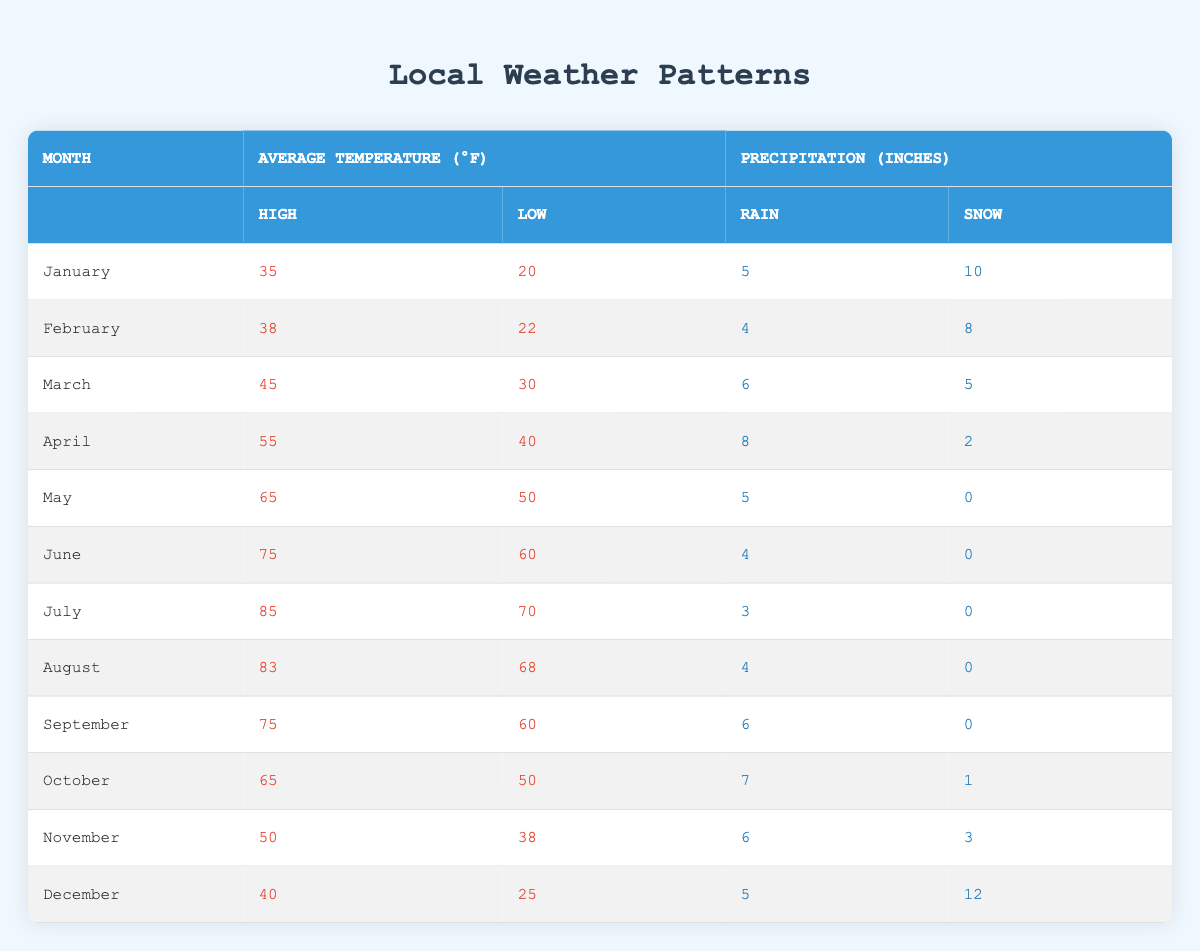What is the average high temperature in June? The high temperature for June is listed as 75°F in the table. Since we are looking for the average and there is only one value for June, the average high temperature equals the high for that month.
Answer: 75°F In which month do we see the highest low temperature? By inspecting the table, the highest low temperature is found in July, which is 70°F. This is the highest value of the low temperatures provided for all months.
Answer: July What is the total amount of snow precipitation in December and November combined? For December, the snowfall is 12 inches, and for November, it is 3 inches. Adding these values together gives us a total of 12 + 3 = 15 inches of snow in both months combined.
Answer: 15 inches Does February have higher rain precipitation than March? In February, the rain is recorded at 4 inches, while in March, it is at 6 inches. Since 4 is less than 6, February does not have higher rain precipitation than March.
Answer: No What is the average low temperature from May to August? The low temperatures for those months are as follows: May - 50°F, June - 60°F, July - 70°F, and August - 68°F. To find the average, we add these values: 50 + 60 + 70 + 68 = 248. Then, we divide by 4 (the number of months) which gives us 248 / 4 = 62°F as the average low temperature.
Answer: 62°F Which month has the least amount of snow precipitation? In the table, May and June both have 0 inches of snow precipitation. Therefore, both months share the least amount of snow.
Answer: May and June What is the difference in average temperatures between January and April? The average high temperature for January is 35°F, and for April, it is 55°F. To find the difference, we subtract January's high from April's: 55 - 35 = 20°F. The average low temperatures follow the same pattern: January's low is 20°F and April's low is 40°F, thus: 40 - 20 = 20°F.
Answer: 20°F difference in both high and low temperatures Which month has lower total precipitation, February or April? February has 4 inches of rain and 8 inches of snow, totaling 12 inches, while April has 8 inches of rain and 2 inches of snow, totaling 10 inches. Since 10 is less than 12, April has lower total precipitation than February.
Answer: April 